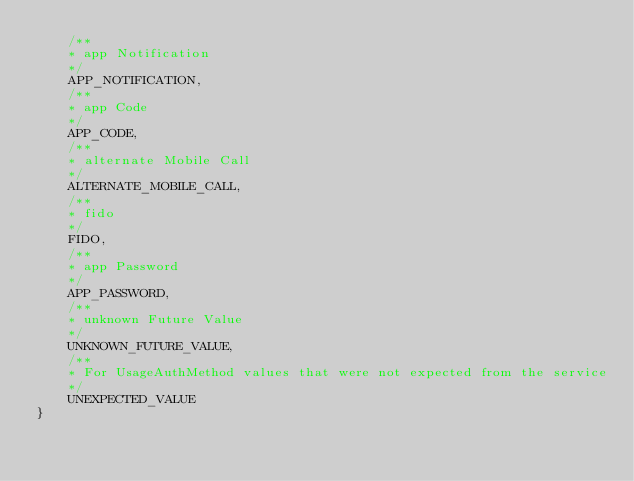<code> <loc_0><loc_0><loc_500><loc_500><_Java_>    /**
    * app Notification
    */
    APP_NOTIFICATION,
    /**
    * app Code
    */
    APP_CODE,
    /**
    * alternate Mobile Call
    */
    ALTERNATE_MOBILE_CALL,
    /**
    * fido
    */
    FIDO,
    /**
    * app Password
    */
    APP_PASSWORD,
    /**
    * unknown Future Value
    */
    UNKNOWN_FUTURE_VALUE,
    /**
    * For UsageAuthMethod values that were not expected from the service
    */
    UNEXPECTED_VALUE
}
</code> 